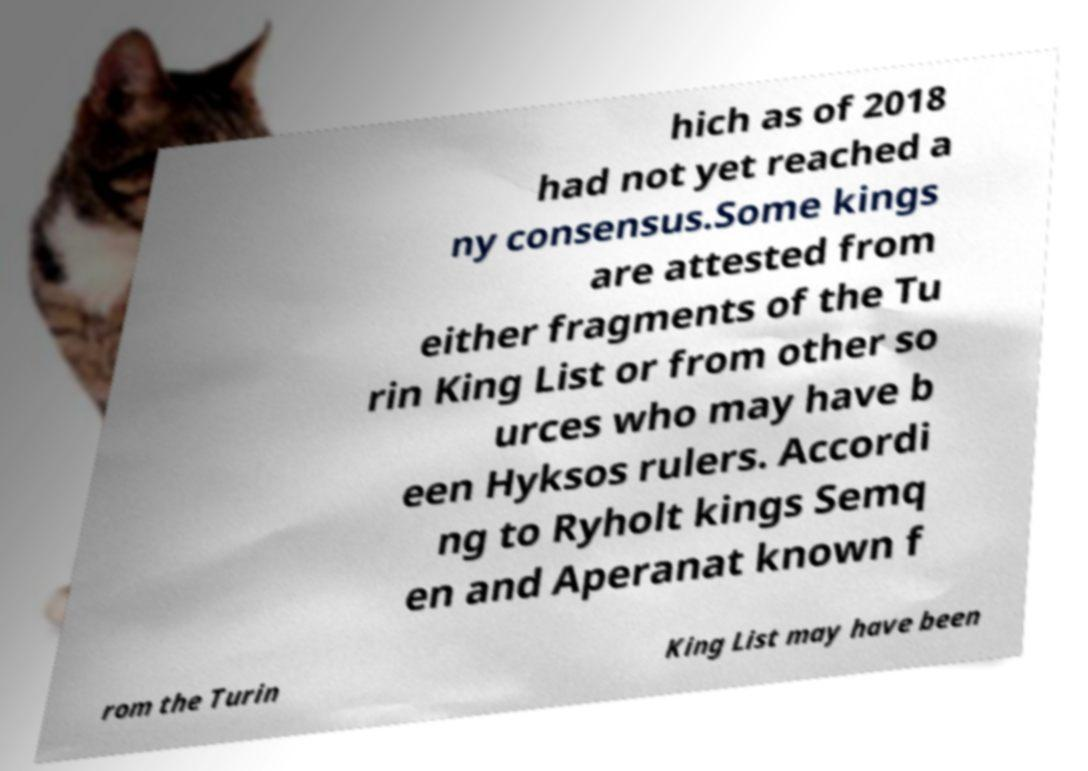Could you extract and type out the text from this image? hich as of 2018 had not yet reached a ny consensus.Some kings are attested from either fragments of the Tu rin King List or from other so urces who may have b een Hyksos rulers. Accordi ng to Ryholt kings Semq en and Aperanat known f rom the Turin King List may have been 